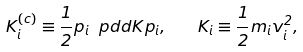<formula> <loc_0><loc_0><loc_500><loc_500>K _ { i } ^ { ( c ) } \equiv \frac { 1 } { 2 } p _ { i } \ p d d { K } { p _ { i } } , \quad K _ { i } \equiv \frac { 1 } { 2 } m _ { i } v _ { i } ^ { 2 } ,</formula> 